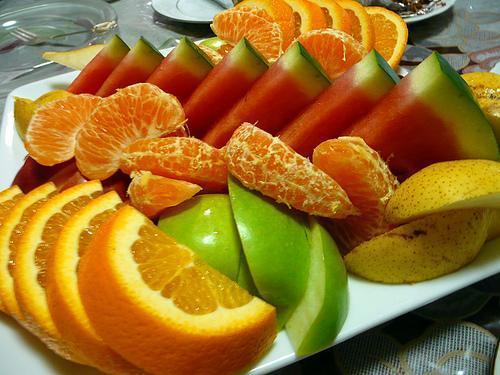How many different fruits are on the plate?
Give a very brief answer. 4. How many dining tables can be seen?
Give a very brief answer. 2. How many apples are there?
Give a very brief answer. 3. How many oranges are in the photo?
Give a very brief answer. 8. 